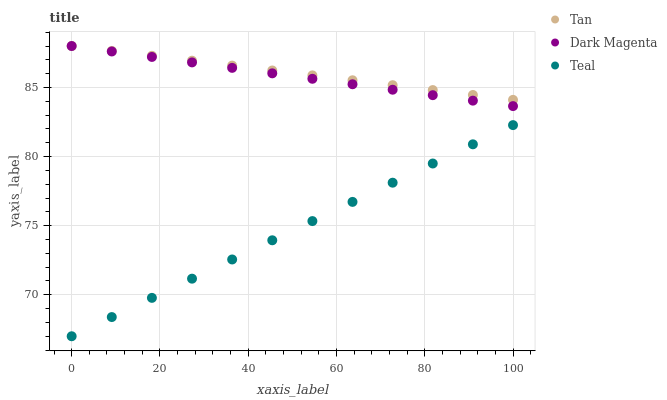Does Teal have the minimum area under the curve?
Answer yes or no. Yes. Does Tan have the maximum area under the curve?
Answer yes or no. Yes. Does Dark Magenta have the minimum area under the curve?
Answer yes or no. No. Does Dark Magenta have the maximum area under the curve?
Answer yes or no. No. Is Tan the smoothest?
Answer yes or no. Yes. Is Dark Magenta the roughest?
Answer yes or no. Yes. Is Teal the smoothest?
Answer yes or no. No. Is Teal the roughest?
Answer yes or no. No. Does Teal have the lowest value?
Answer yes or no. Yes. Does Dark Magenta have the lowest value?
Answer yes or no. No. Does Dark Magenta have the highest value?
Answer yes or no. Yes. Does Teal have the highest value?
Answer yes or no. No. Is Teal less than Dark Magenta?
Answer yes or no. Yes. Is Dark Magenta greater than Teal?
Answer yes or no. Yes. Does Tan intersect Dark Magenta?
Answer yes or no. Yes. Is Tan less than Dark Magenta?
Answer yes or no. No. Is Tan greater than Dark Magenta?
Answer yes or no. No. Does Teal intersect Dark Magenta?
Answer yes or no. No. 